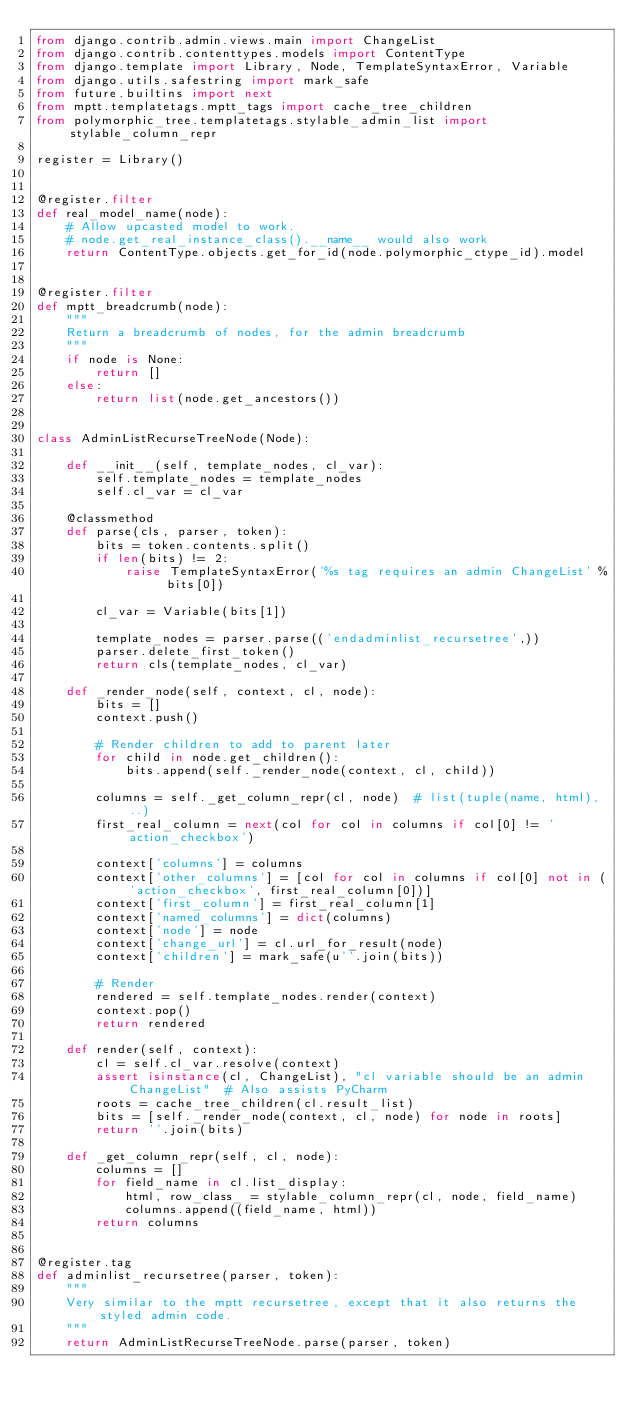<code> <loc_0><loc_0><loc_500><loc_500><_Python_>from django.contrib.admin.views.main import ChangeList
from django.contrib.contenttypes.models import ContentType
from django.template import Library, Node, TemplateSyntaxError, Variable
from django.utils.safestring import mark_safe
from future.builtins import next
from mptt.templatetags.mptt_tags import cache_tree_children
from polymorphic_tree.templatetags.stylable_admin_list import stylable_column_repr

register = Library()


@register.filter
def real_model_name(node):
    # Allow upcasted model to work.
    # node.get_real_instance_class().__name__ would also work
    return ContentType.objects.get_for_id(node.polymorphic_ctype_id).model


@register.filter
def mptt_breadcrumb(node):
    """
    Return a breadcrumb of nodes, for the admin breadcrumb
    """
    if node is None:
        return []
    else:
        return list(node.get_ancestors())


class AdminListRecurseTreeNode(Node):

    def __init__(self, template_nodes, cl_var):
        self.template_nodes = template_nodes
        self.cl_var = cl_var

    @classmethod
    def parse(cls, parser, token):
        bits = token.contents.split()
        if len(bits) != 2:
            raise TemplateSyntaxError('%s tag requires an admin ChangeList' % bits[0])

        cl_var = Variable(bits[1])

        template_nodes = parser.parse(('endadminlist_recursetree',))
        parser.delete_first_token()
        return cls(template_nodes, cl_var)

    def _render_node(self, context, cl, node):
        bits = []
        context.push()

        # Render children to add to parent later
        for child in node.get_children():
            bits.append(self._render_node(context, cl, child))

        columns = self._get_column_repr(cl, node)  # list(tuple(name, html), ..)
        first_real_column = next(col for col in columns if col[0] != 'action_checkbox')

        context['columns'] = columns
        context['other_columns'] = [col for col in columns if col[0] not in ('action_checkbox', first_real_column[0])]
        context['first_column'] = first_real_column[1]
        context['named_columns'] = dict(columns)
        context['node'] = node
        context['change_url'] = cl.url_for_result(node)
        context['children'] = mark_safe(u''.join(bits))

        # Render
        rendered = self.template_nodes.render(context)
        context.pop()
        return rendered

    def render(self, context):
        cl = self.cl_var.resolve(context)
        assert isinstance(cl, ChangeList), "cl variable should be an admin ChangeList"  # Also assists PyCharm
        roots = cache_tree_children(cl.result_list)
        bits = [self._render_node(context, cl, node) for node in roots]
        return ''.join(bits)

    def _get_column_repr(self, cl, node):
        columns = []
        for field_name in cl.list_display:
            html, row_class_ = stylable_column_repr(cl, node, field_name)
            columns.append((field_name, html))
        return columns


@register.tag
def adminlist_recursetree(parser, token):
    """
    Very similar to the mptt recursetree, except that it also returns the styled admin code.
    """
    return AdminListRecurseTreeNode.parse(parser, token)
</code> 